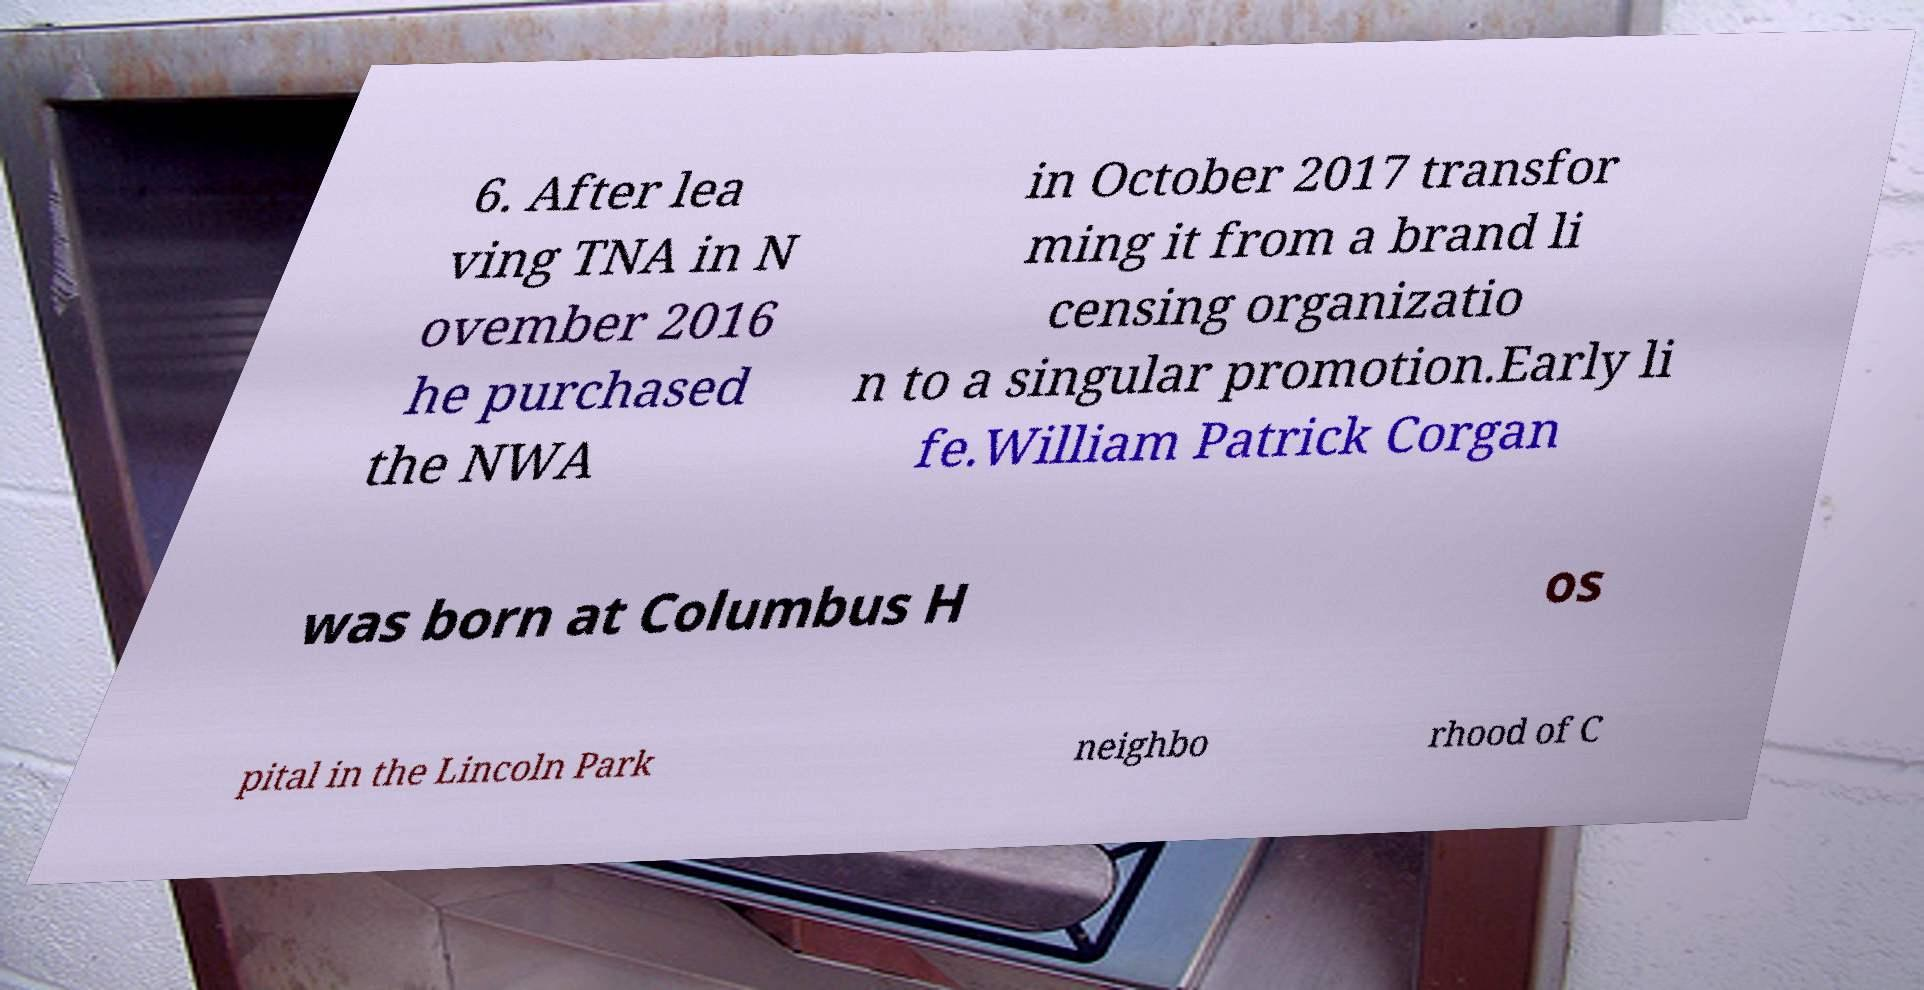Could you assist in decoding the text presented in this image and type it out clearly? 6. After lea ving TNA in N ovember 2016 he purchased the NWA in October 2017 transfor ming it from a brand li censing organizatio n to a singular promotion.Early li fe.William Patrick Corgan was born at Columbus H os pital in the Lincoln Park neighbo rhood of C 